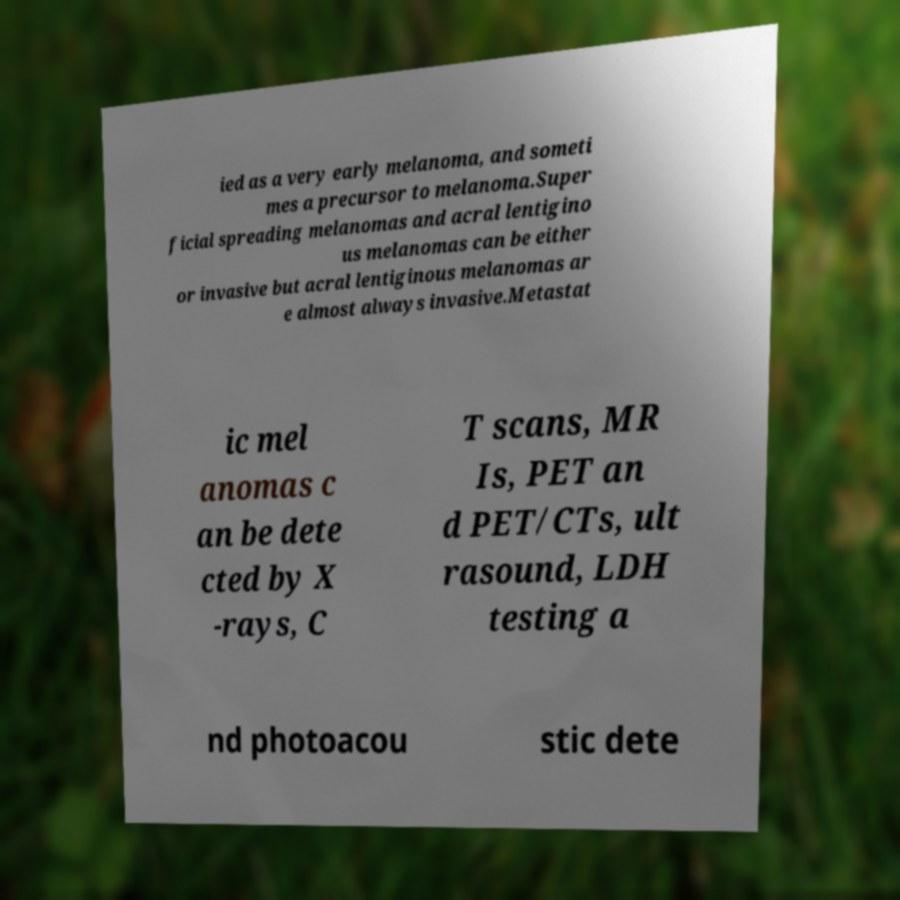What messages or text are displayed in this image? I need them in a readable, typed format. ied as a very early melanoma, and someti mes a precursor to melanoma.Super ficial spreading melanomas and acral lentigino us melanomas can be either or invasive but acral lentiginous melanomas ar e almost always invasive.Metastat ic mel anomas c an be dete cted by X -rays, C T scans, MR Is, PET an d PET/CTs, ult rasound, LDH testing a nd photoacou stic dete 